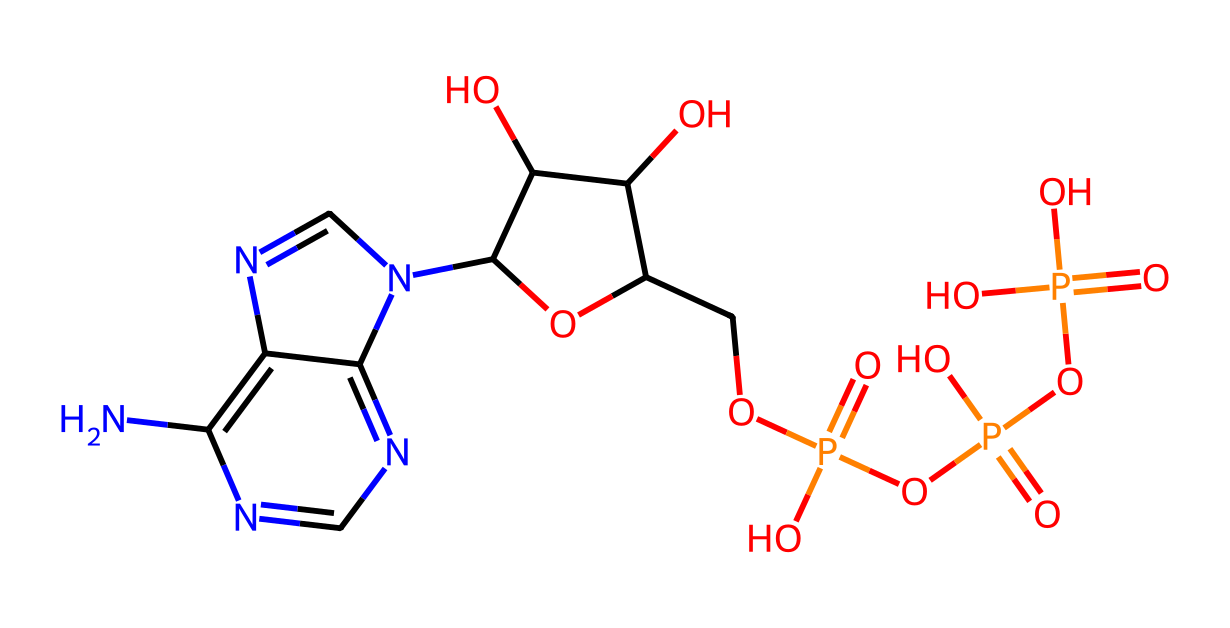What is the molecular formula of ATP based on its structure? By analyzing the structure derived from the SMILES representation, we can count the number of each type of atom present. For ATP, there are 10 carbon (C) atoms, 14 hydrogen (H) atoms, 5 nitrogen (N) atoms, 4 oxygen (O) atoms, and 1 phosphorus (P) atom. Thus, the molecular formula can be written as C10H14N5O7P.
Answer: C10H14N5O7P How many phosphate groups does ATP have? In the representation of ATP, we can identify three distinct phosphate (P) groups. Each phosphate group is indicated by the 'P' in the structure and their connections.
Answer: 3 What type of chemical bond connects the phosphate groups to the ribose sugar in ATP? The phosphate groups are connected to the ribose sugar through phosphoester bonds. These bonds are formed when a phosphate group reacts with an alcohol group on the ribose sugar, resulting in the formation of an ester linkage typical of nucleotides like ATP.
Answer: phosphoester What functional groups are present in ATP? By examining the structure, we can identify several functional groups in ATP, including hydroxyl (–OH) groups and phosphate groups (–PO4). These groups contribute to ATP's properties and function in energy transfer.
Answer: hydroxyl and phosphate What is the role of ATP in biological systems? ATP serves as the primary energy currency of cells, functioning as a source of energy to power various biochemical processes, including muscle contraction, nerve impulse propagation, and biosynthetic reactions.
Answer: energy currency How does the structure of ATP contribute to its high-energy nature? The high-energy nature of ATP can be attributed to the presence of the three phosphate groups, which are connected by high-energy phosphoanhydride bonds. The hydrolysis of these bonds releases significant energy that is harnessed by the cell for metabolic processes.
Answer: high-energy phosphate bonds 